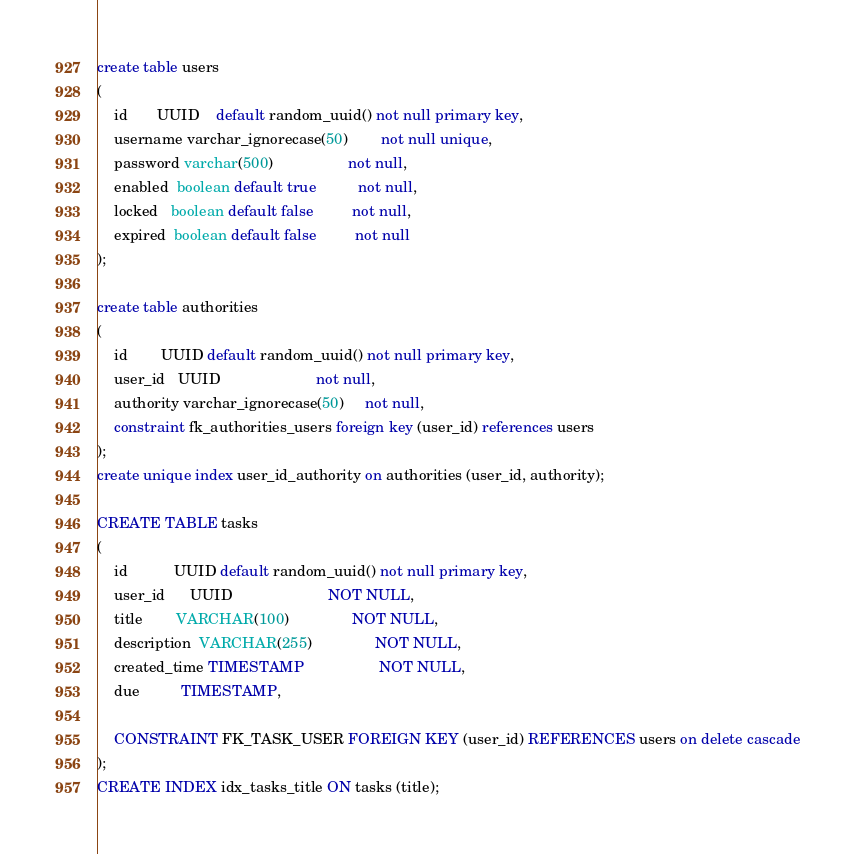<code> <loc_0><loc_0><loc_500><loc_500><_SQL_>create table users
(
    id       UUID    default random_uuid() not null primary key,
    username varchar_ignorecase(50)        not null unique,
    password varchar(500)                  not null,
    enabled  boolean default true          not null,
    locked   boolean default false         not null,
    expired  boolean default false         not null
);

create table authorities
(
    id        UUID default random_uuid() not null primary key,
    user_id   UUID                       not null,
    authority varchar_ignorecase(50)     not null,
    constraint fk_authorities_users foreign key (user_id) references users
);
create unique index user_id_authority on authorities (user_id, authority);

CREATE TABLE tasks
(
    id           UUID default random_uuid() not null primary key,
    user_id      UUID                       NOT NULL,
    title        VARCHAR(100)               NOT NULL,
    description  VARCHAR(255)               NOT NULL,
    created_time TIMESTAMP                  NOT NULL,
    due          TIMESTAMP,

    CONSTRAINT FK_TASK_USER FOREIGN KEY (user_id) REFERENCES users on delete cascade
);
CREATE INDEX idx_tasks_title ON tasks (title);
</code> 